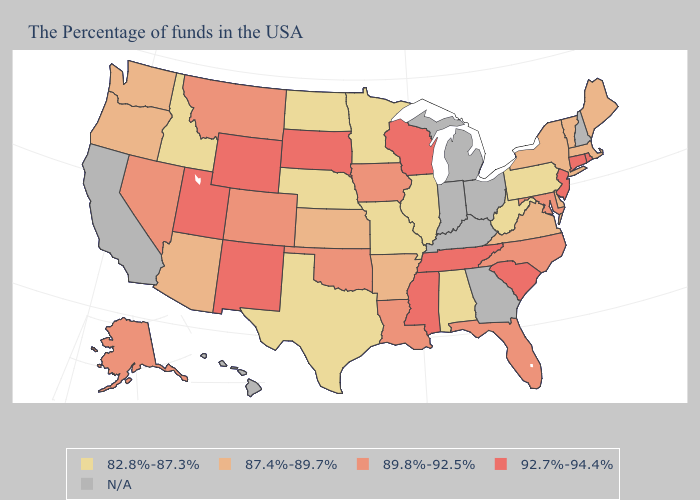Does the first symbol in the legend represent the smallest category?
Be succinct. Yes. Among the states that border Louisiana , which have the highest value?
Write a very short answer. Mississippi. What is the value of Idaho?
Be succinct. 82.8%-87.3%. Does Iowa have the lowest value in the MidWest?
Write a very short answer. No. What is the lowest value in the Northeast?
Quick response, please. 82.8%-87.3%. Among the states that border South Dakota , does North Dakota have the lowest value?
Concise answer only. Yes. Among the states that border Kansas , does Missouri have the highest value?
Concise answer only. No. Does the first symbol in the legend represent the smallest category?
Write a very short answer. Yes. Is the legend a continuous bar?
Quick response, please. No. What is the value of West Virginia?
Quick response, please. 82.8%-87.3%. What is the lowest value in states that border Washington?
Quick response, please. 82.8%-87.3%. Does Connecticut have the lowest value in the Northeast?
Short answer required. No. Which states have the lowest value in the MidWest?
Give a very brief answer. Illinois, Missouri, Minnesota, Nebraska, North Dakota. Name the states that have a value in the range 89.8%-92.5%?
Quick response, please. Maryland, North Carolina, Florida, Louisiana, Iowa, Oklahoma, Colorado, Montana, Nevada, Alaska. 